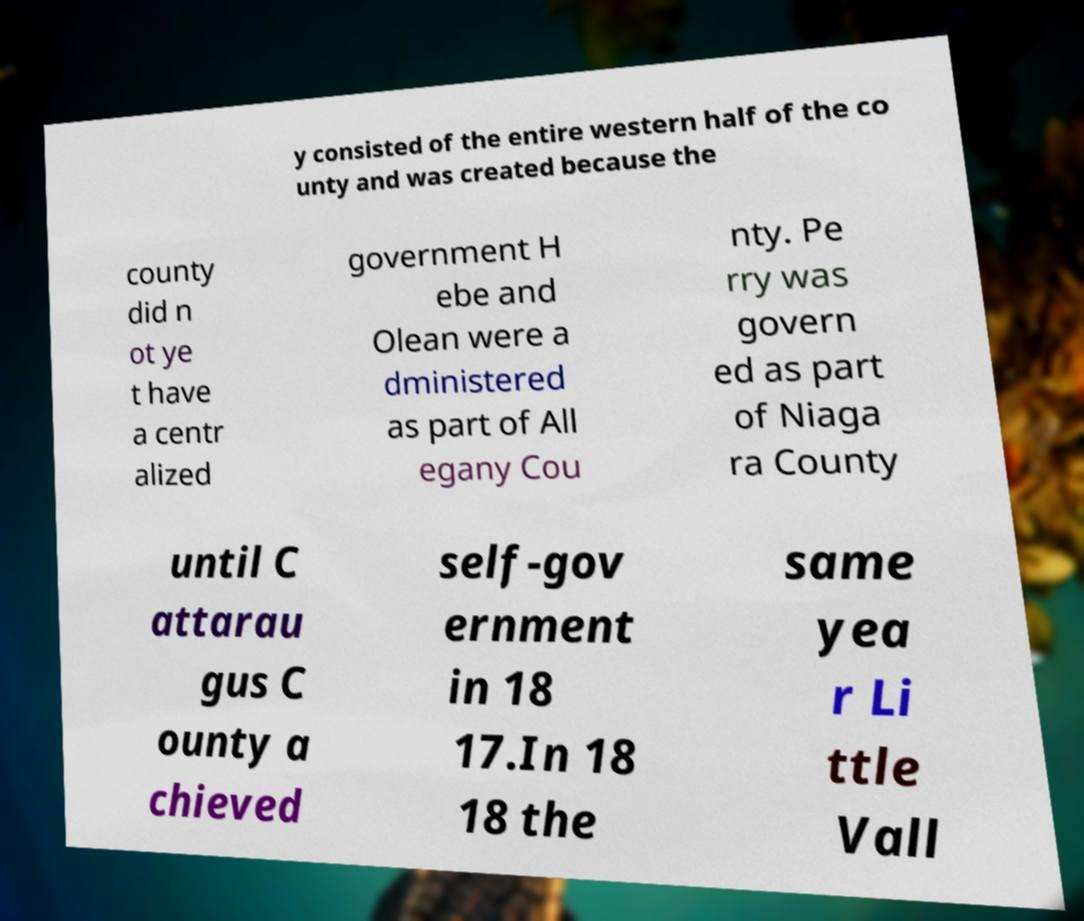Please identify and transcribe the text found in this image. y consisted of the entire western half of the co unty and was created because the county did n ot ye t have a centr alized government H ebe and Olean were a dministered as part of All egany Cou nty. Pe rry was govern ed as part of Niaga ra County until C attarau gus C ounty a chieved self-gov ernment in 18 17.In 18 18 the same yea r Li ttle Vall 